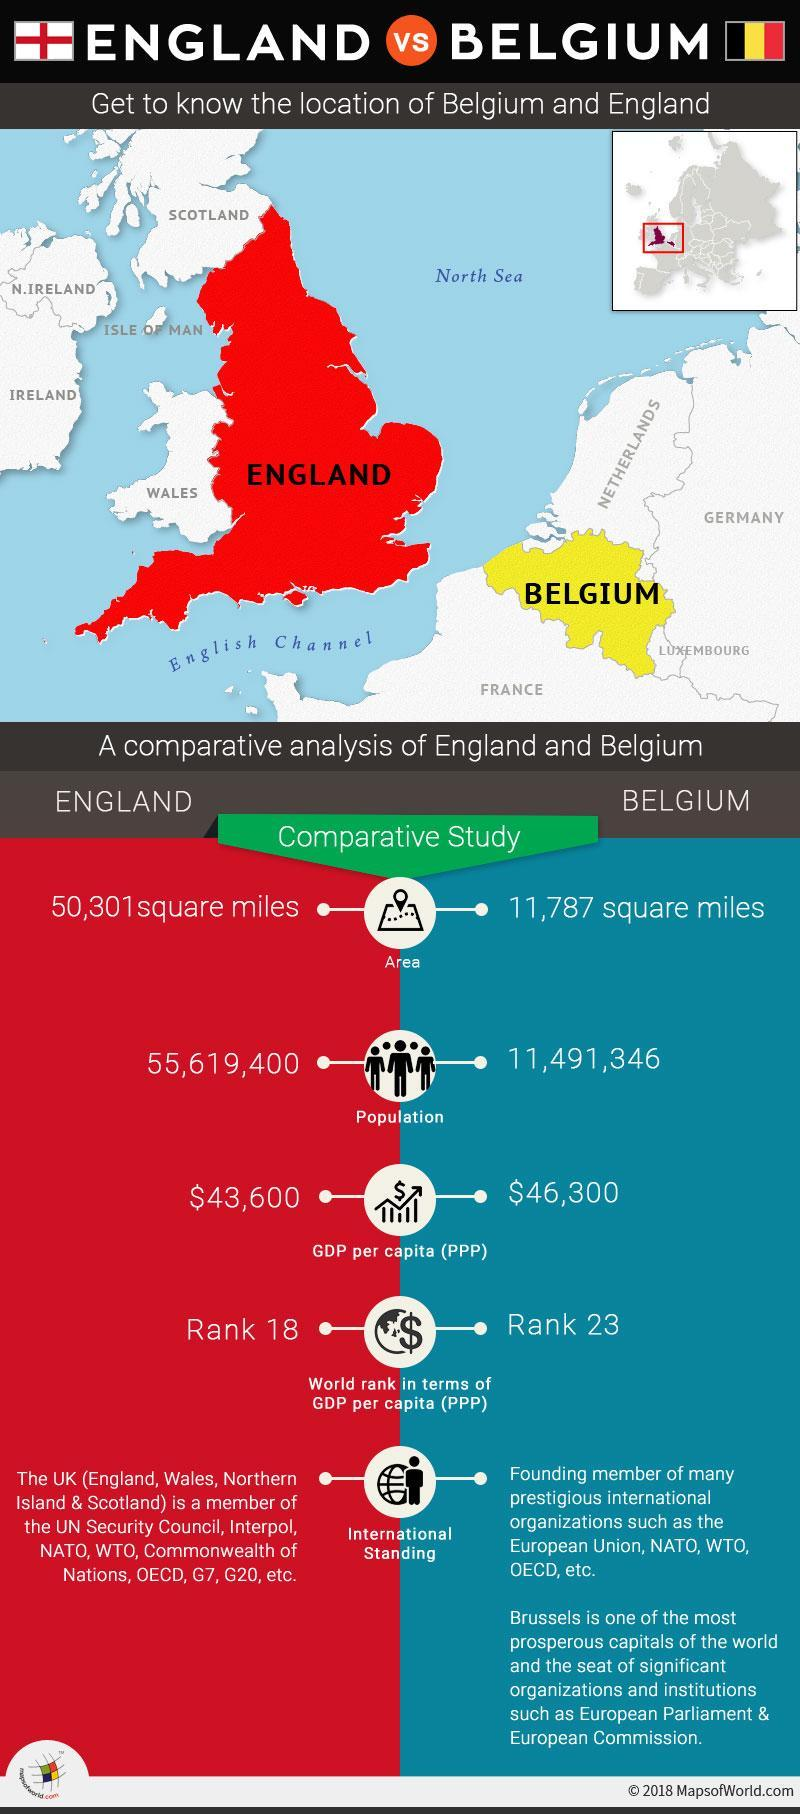Which colour is Belgium shown, red or yellow?
Answer the question with a short phrase. yellow How much higher is England's population than Belgium 44128054 Which colour is England shown, red or yellow? red Which country has a higher GDP Belgium Which water body is between France and England English Channel Which country is below Belgium France 